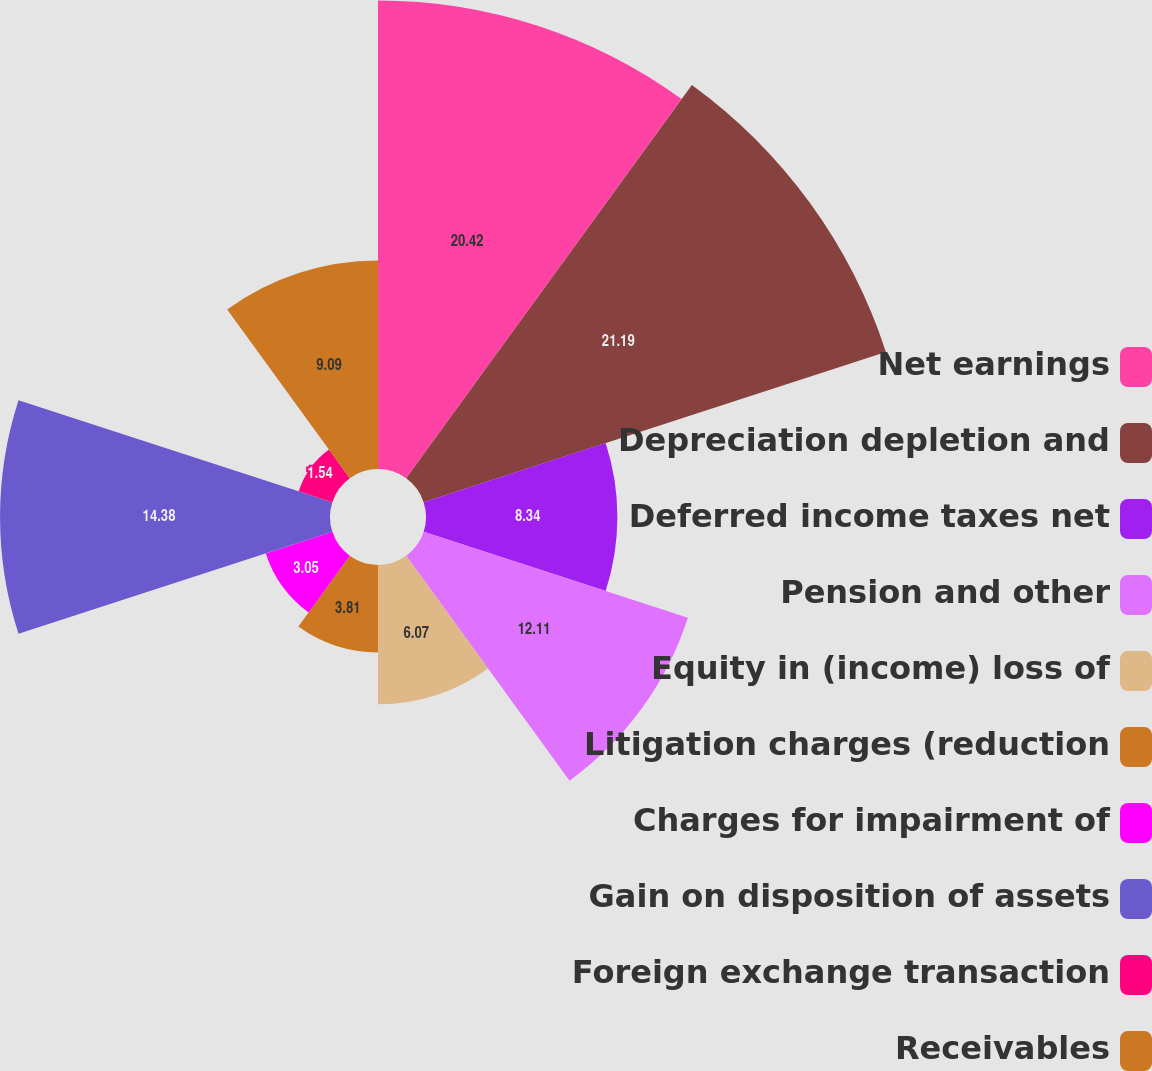<chart> <loc_0><loc_0><loc_500><loc_500><pie_chart><fcel>Net earnings<fcel>Depreciation depletion and<fcel>Deferred income taxes net<fcel>Pension and other<fcel>Equity in (income) loss of<fcel>Litigation charges (reduction<fcel>Charges for impairment of<fcel>Gain on disposition of assets<fcel>Foreign exchange transaction<fcel>Receivables<nl><fcel>20.42%<fcel>21.18%<fcel>8.34%<fcel>12.11%<fcel>6.07%<fcel>3.81%<fcel>3.05%<fcel>14.38%<fcel>1.54%<fcel>9.09%<nl></chart> 